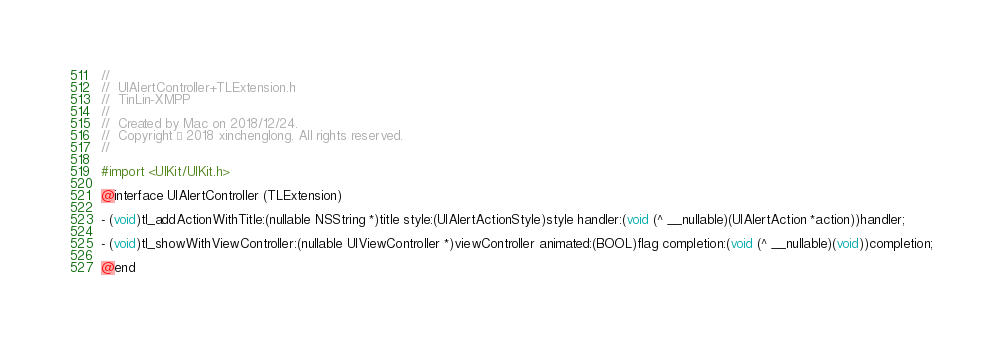<code> <loc_0><loc_0><loc_500><loc_500><_C_>//
//  UIAlertController+TLExtension.h
//  TinLin-XMPP
//
//  Created by Mac on 2018/12/24.
//  Copyright © 2018 xinchenglong. All rights reserved.
//

#import <UIKit/UIKit.h>

@interface UIAlertController (TLExtension)

- (void)tl_addActionWithTitle:(nullable NSString *)title style:(UIAlertActionStyle)style handler:(void (^ __nullable)(UIAlertAction *action))handler;

- (void)tl_showWithViewController:(nullable UIViewController *)viewController animated:(BOOL)flag completion:(void (^ __nullable)(void))completion;

@end
</code> 